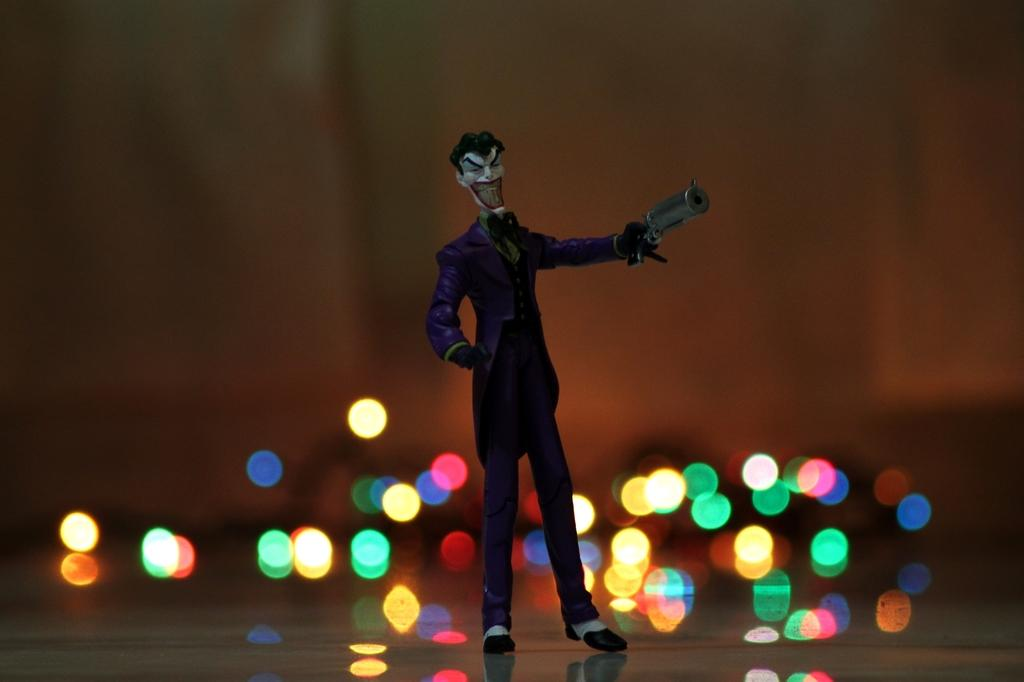What is located in the foreground of the image? There is a toy and a light in the foreground of the image. How does the toy help the sofa in the image? There is no sofa present in the image, and therefore the toy cannot help it. 